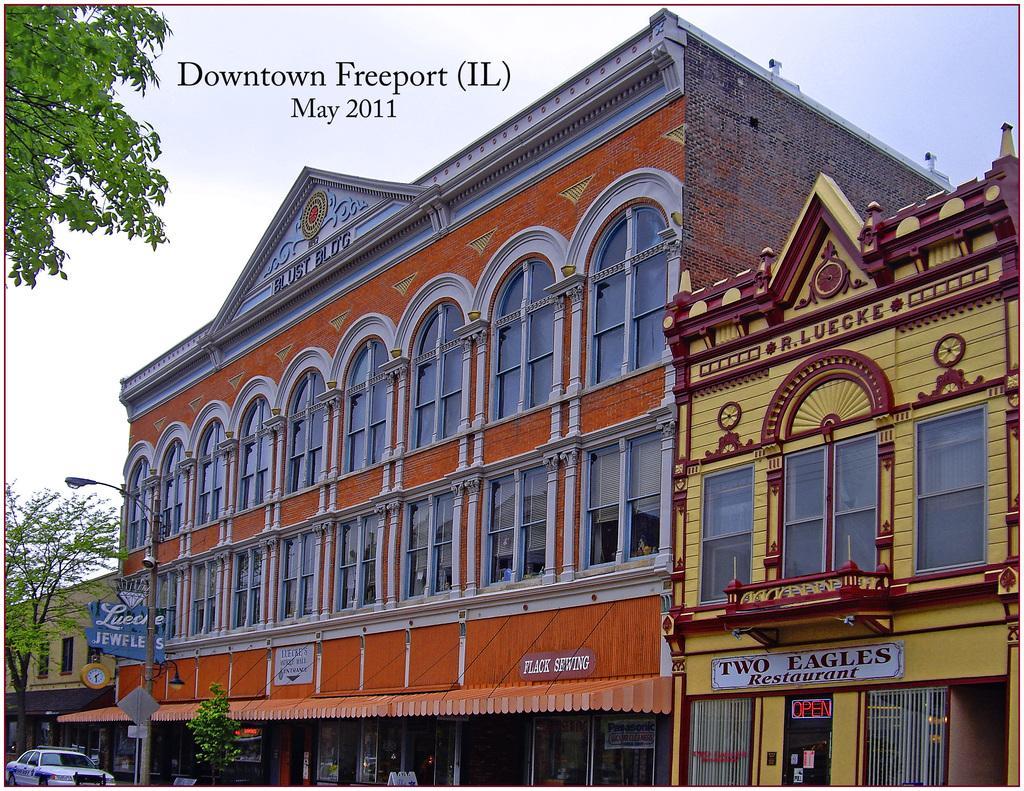Can you describe this image briefly? In this picture we can see few buildings, hoardings, a pole, lights and sign boards, at the left bottom of the image we can see a car, in the background we can find few trees. On top of the image we can see some text. 